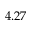<formula> <loc_0><loc_0><loc_500><loc_500>4 . 2 7</formula> 